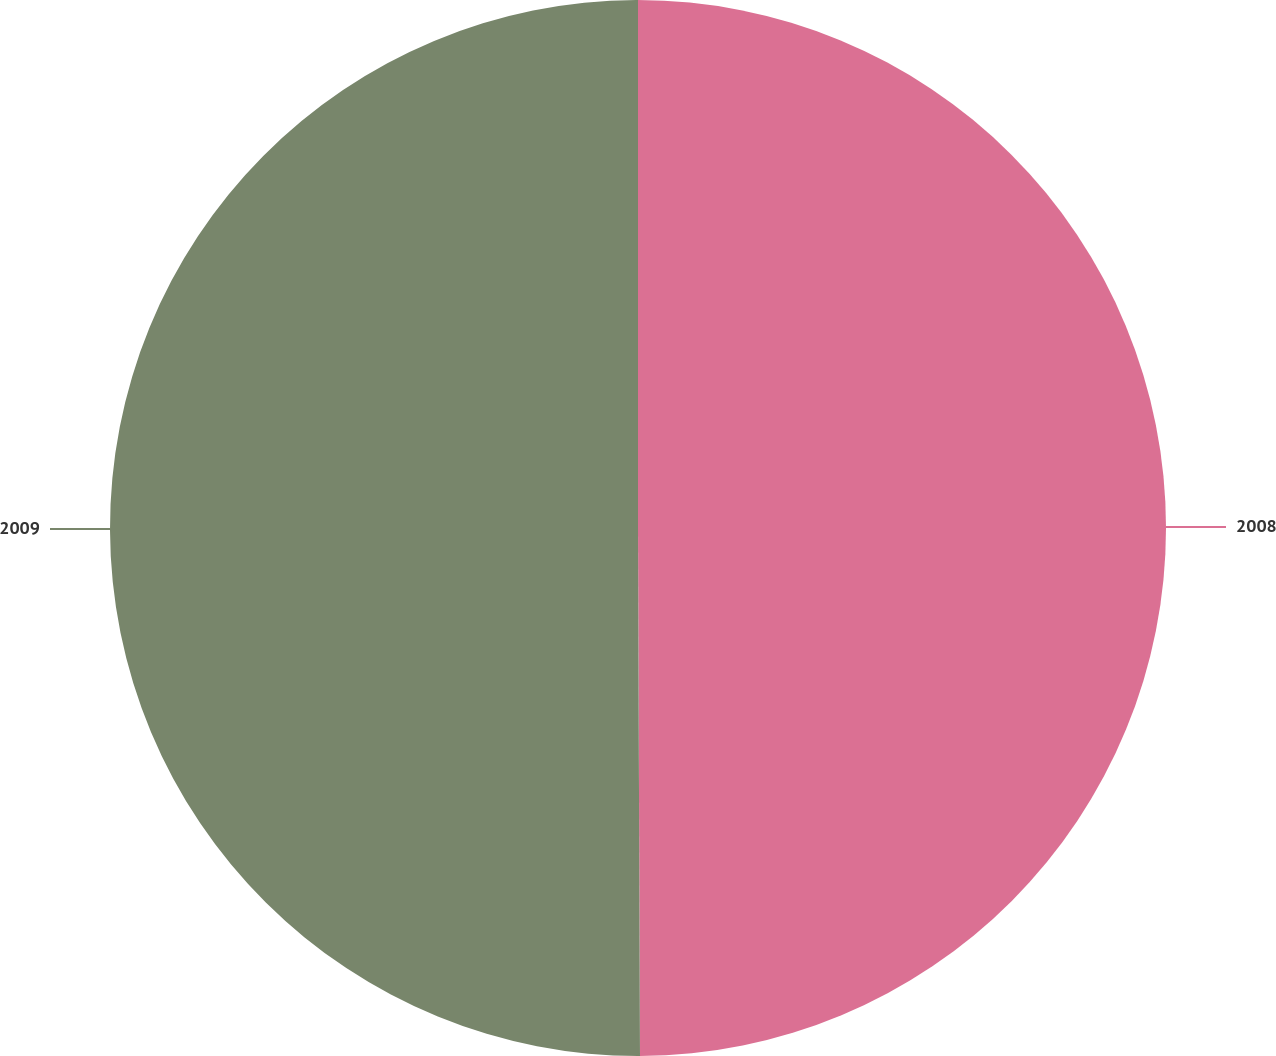Convert chart. <chart><loc_0><loc_0><loc_500><loc_500><pie_chart><fcel>2008<fcel>2009<nl><fcel>49.94%<fcel>50.06%<nl></chart> 